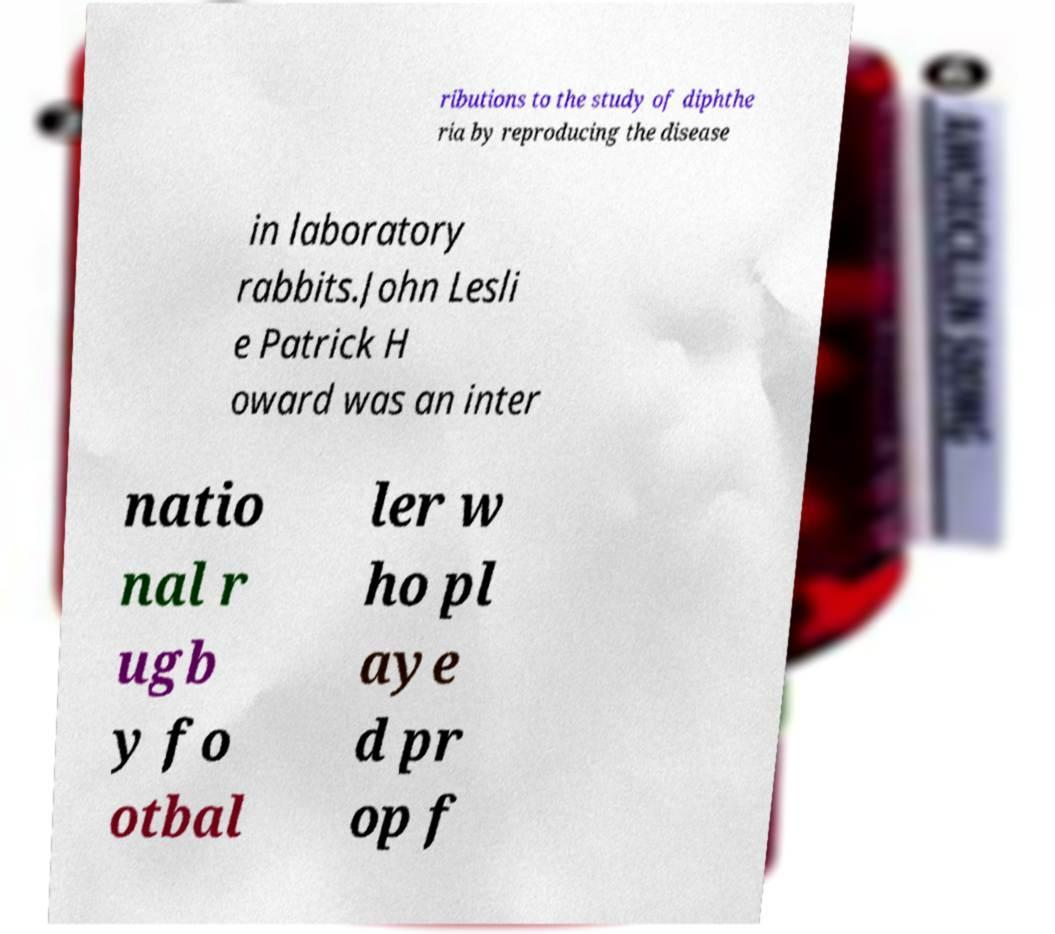Could you assist in decoding the text presented in this image and type it out clearly? ributions to the study of diphthe ria by reproducing the disease in laboratory rabbits.John Lesli e Patrick H oward was an inter natio nal r ugb y fo otbal ler w ho pl aye d pr op f 